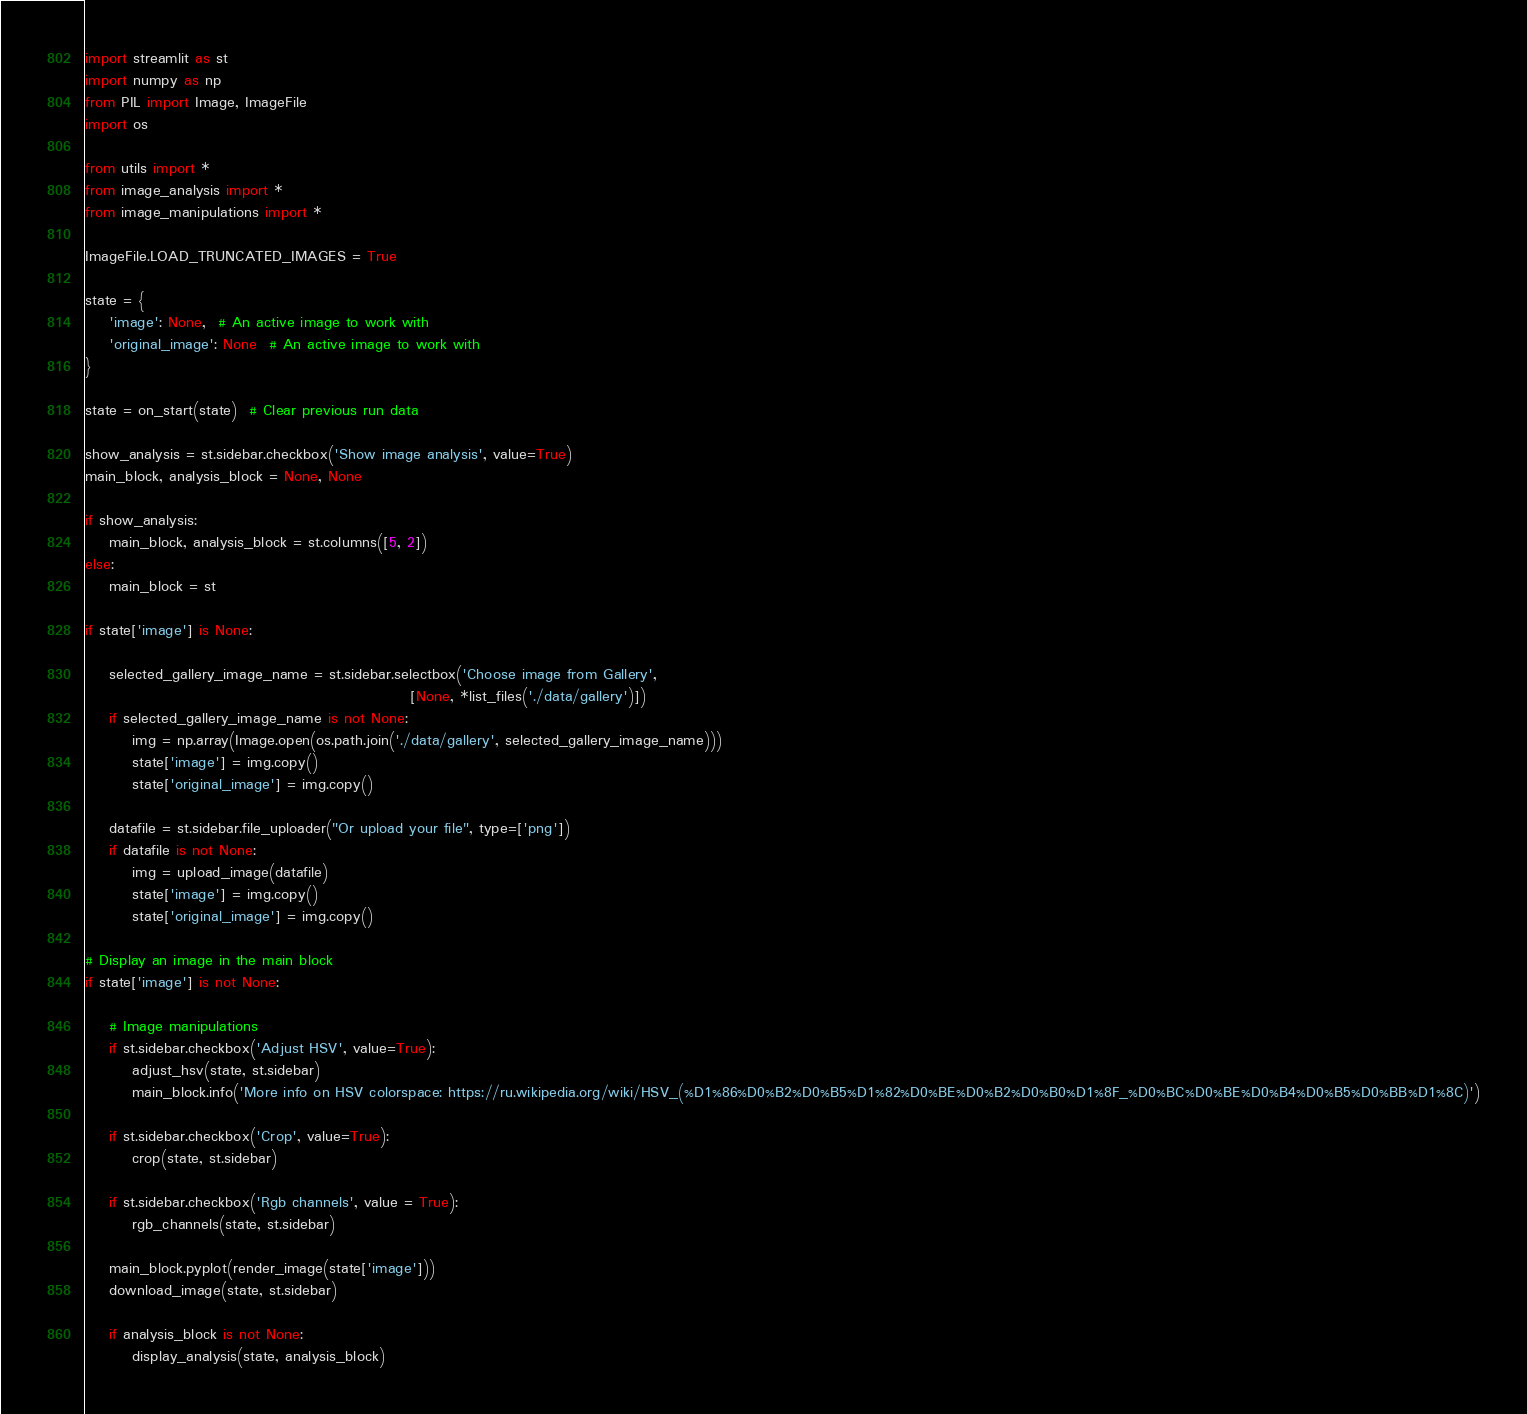<code> <loc_0><loc_0><loc_500><loc_500><_Python_>import streamlit as st
import numpy as np
from PIL import Image, ImageFile
import os

from utils import *
from image_analysis import *
from image_manipulations import *

ImageFile.LOAD_TRUNCATED_IMAGES = True

state = {
    'image': None,  # An active image to work with
    'original_image': None  # An active image to work with
}

state = on_start(state)  # Clear previous run data

show_analysis = st.sidebar.checkbox('Show image analysis', value=True)
main_block, analysis_block = None, None

if show_analysis:
    main_block, analysis_block = st.columns([5, 2])
else:
    main_block = st

if state['image'] is None:

    selected_gallery_image_name = st.sidebar.selectbox('Choose image from Gallery',
                                                       [None, *list_files('./data/gallery')])
    if selected_gallery_image_name is not None:
        img = np.array(Image.open(os.path.join('./data/gallery', selected_gallery_image_name)))
        state['image'] = img.copy()
        state['original_image'] = img.copy()

    datafile = st.sidebar.file_uploader("Or upload your file", type=['png'])
    if datafile is not None:
        img = upload_image(datafile)
        state['image'] = img.copy()
        state['original_image'] = img.copy()

# Display an image in the main block
if state['image'] is not None:

    # Image manipulations
    if st.sidebar.checkbox('Adjust HSV', value=True):
        adjust_hsv(state, st.sidebar)
        main_block.info('More info on HSV colorspace: https://ru.wikipedia.org/wiki/HSV_(%D1%86%D0%B2%D0%B5%D1%82%D0%BE%D0%B2%D0%B0%D1%8F_%D0%BC%D0%BE%D0%B4%D0%B5%D0%BB%D1%8C)')

    if st.sidebar.checkbox('Crop', value=True):
        crop(state, st.sidebar)

    if st.sidebar.checkbox('Rgb channels', value = True):
        rgb_channels(state, st.sidebar)

    main_block.pyplot(render_image(state['image']))
    download_image(state, st.sidebar)

    if analysis_block is not None:
        display_analysis(state, analysis_block)</code> 